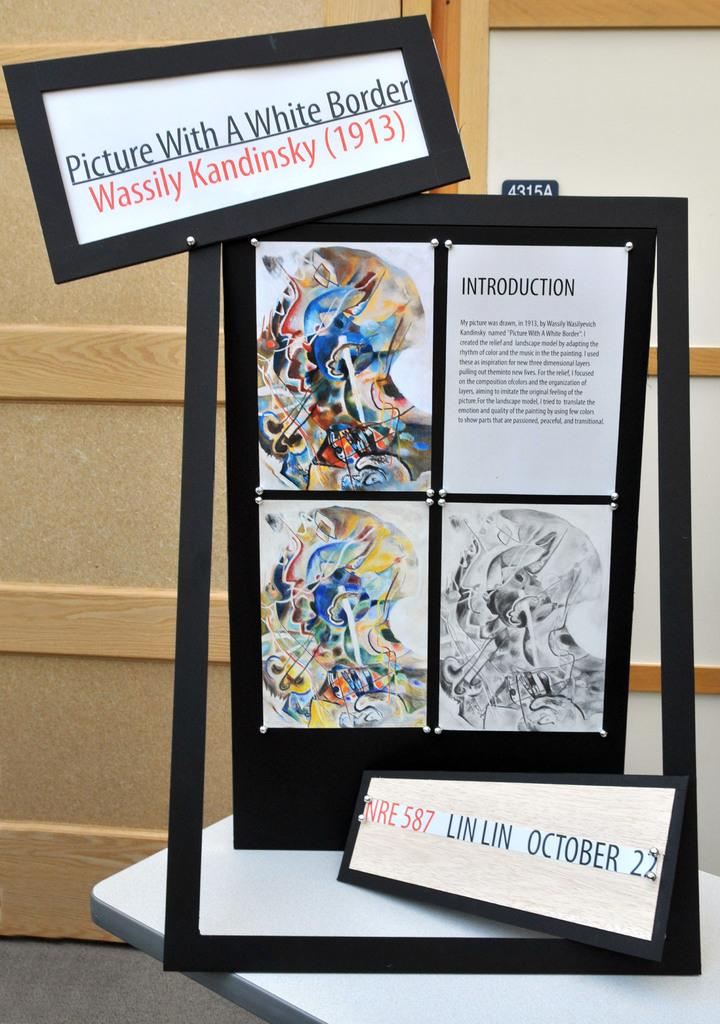<image>
Describe the image concisely. A frame shows three pictures by Wassily Kandinsky and introduction story 